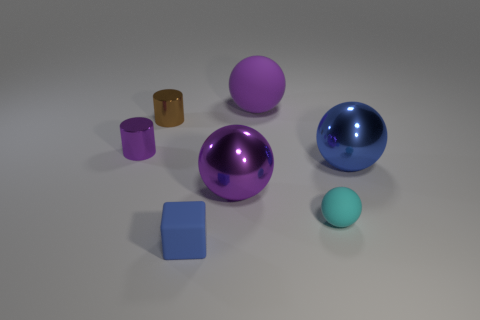Add 1 big cyan matte things. How many objects exist? 8 Subtract all cylinders. How many objects are left? 5 Subtract all cyan matte objects. Subtract all purple metallic objects. How many objects are left? 4 Add 5 tiny purple cylinders. How many tiny purple cylinders are left? 6 Add 3 purple shiny cylinders. How many purple shiny cylinders exist? 4 Subtract 0 green cylinders. How many objects are left? 7 